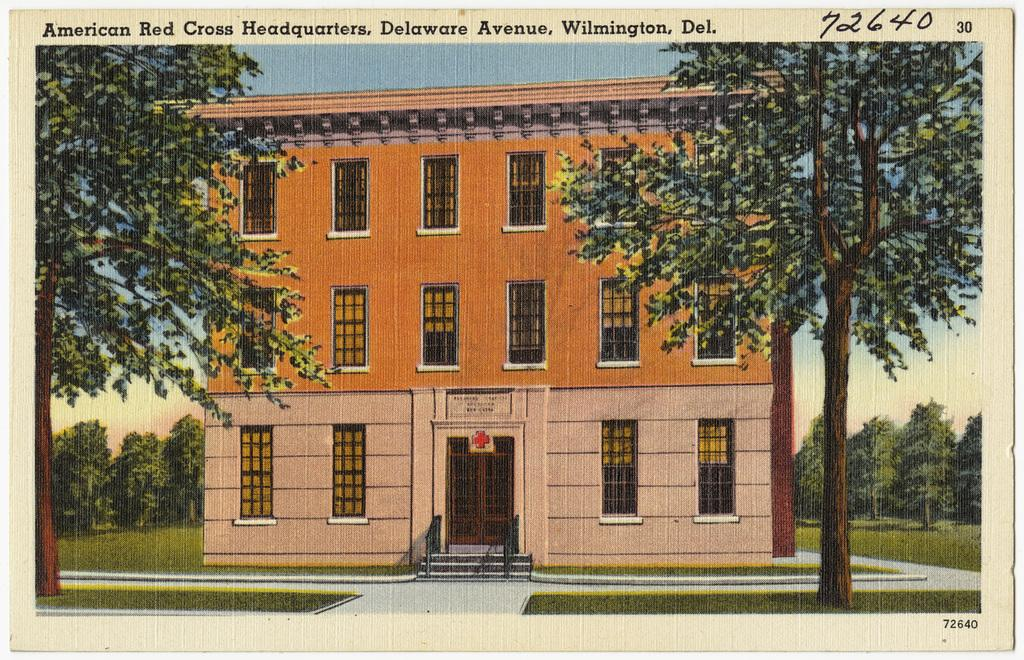What is the main subject of the image? The image contains a photograph. What can be seen in the photograph? The photograph includes a house, windows, trees, and stairs. Is there any text present in the photograph? Yes, there is some written text at the top of the photograph. How many cherries are hanging from the trees in the photograph? There are no cherries visible in the photograph; it only shows trees. Can you see a screw holding the stairs together in the photograph? There is no screw visible in the photograph; it only shows stairs. 